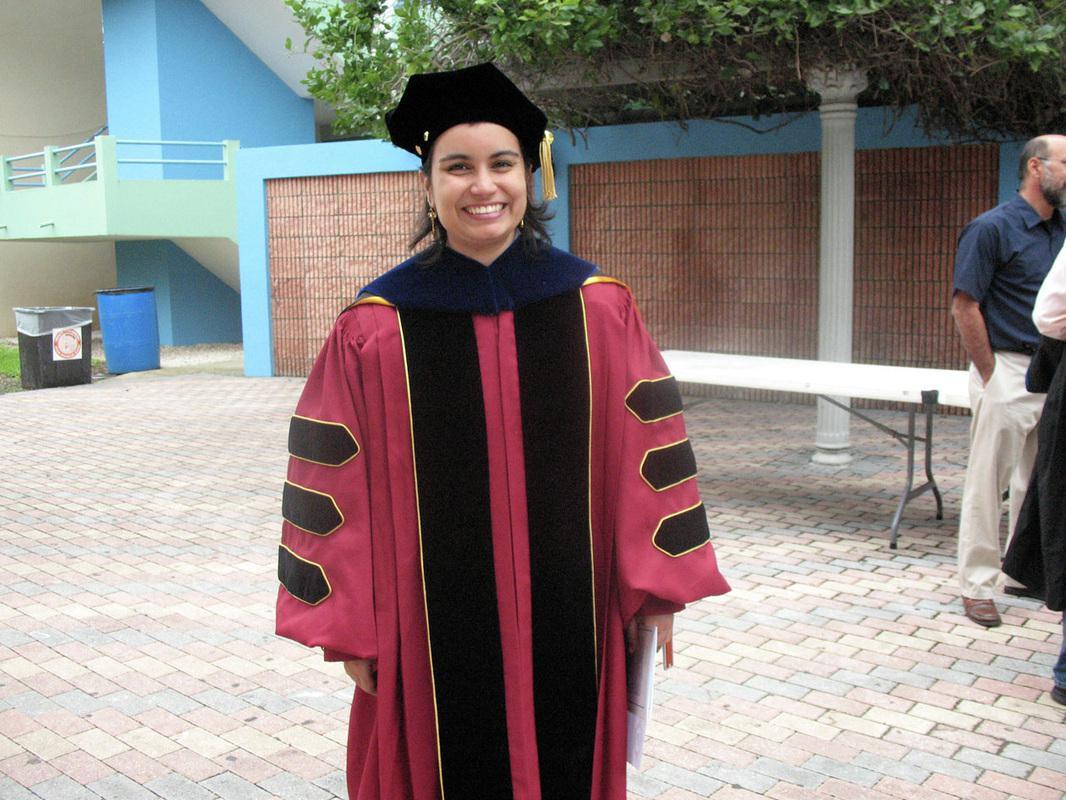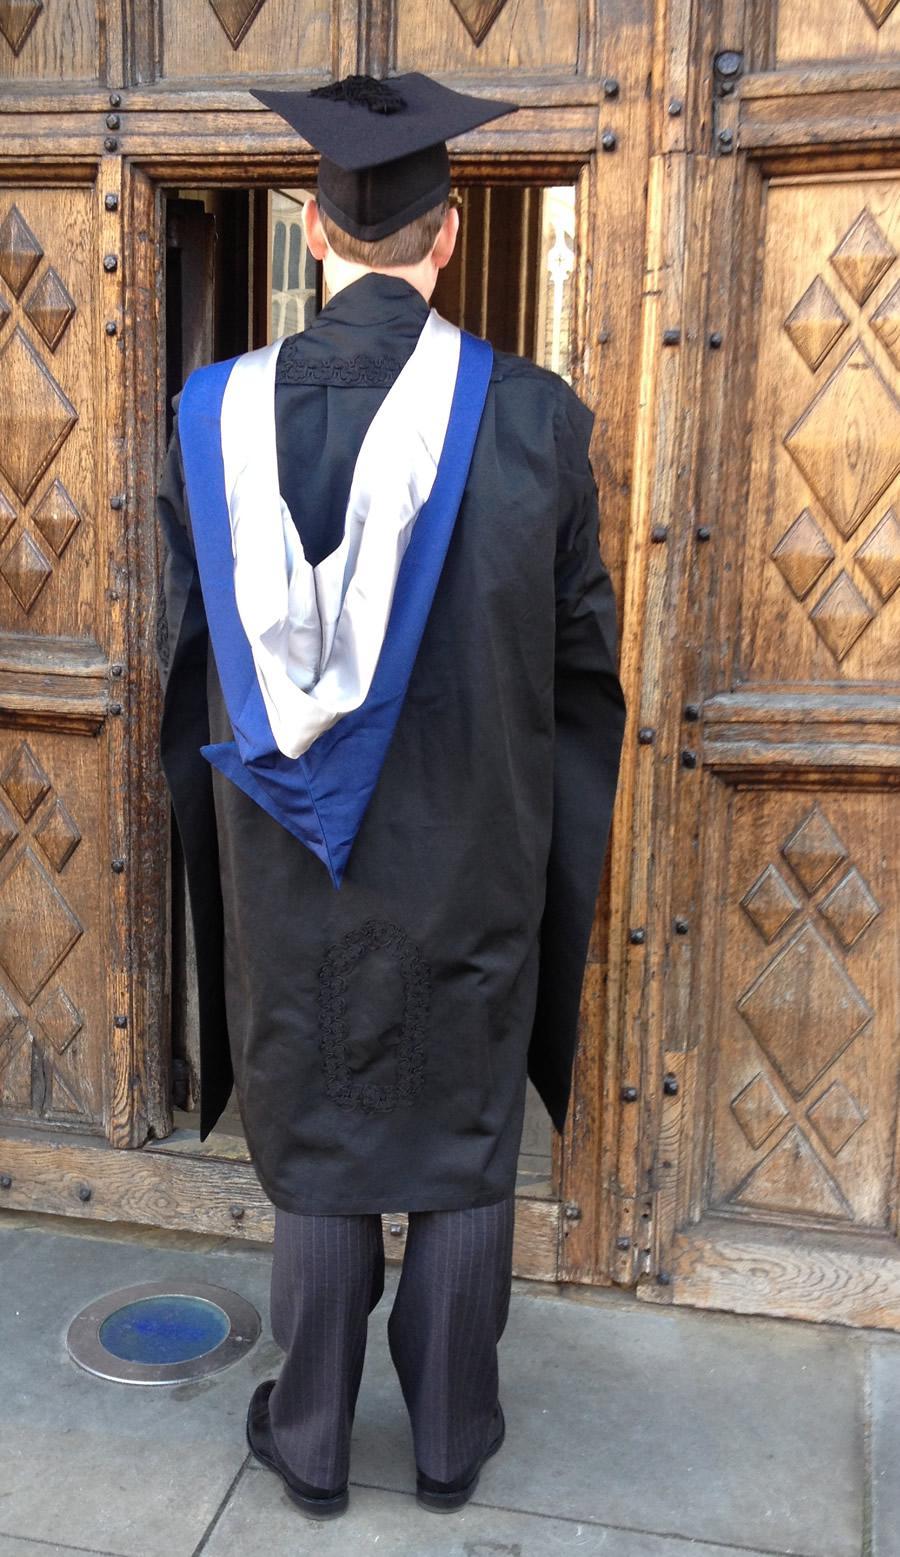The first image is the image on the left, the second image is the image on the right. Examine the images to the left and right. Is the description "The graduate in the left image can be seen smiling." accurate? Answer yes or no. Yes. The first image is the image on the left, the second image is the image on the right. Assess this claim about the two images: "In one of the images, there is only one person, and they are facing away from the camera.". Correct or not? Answer yes or no. Yes. 